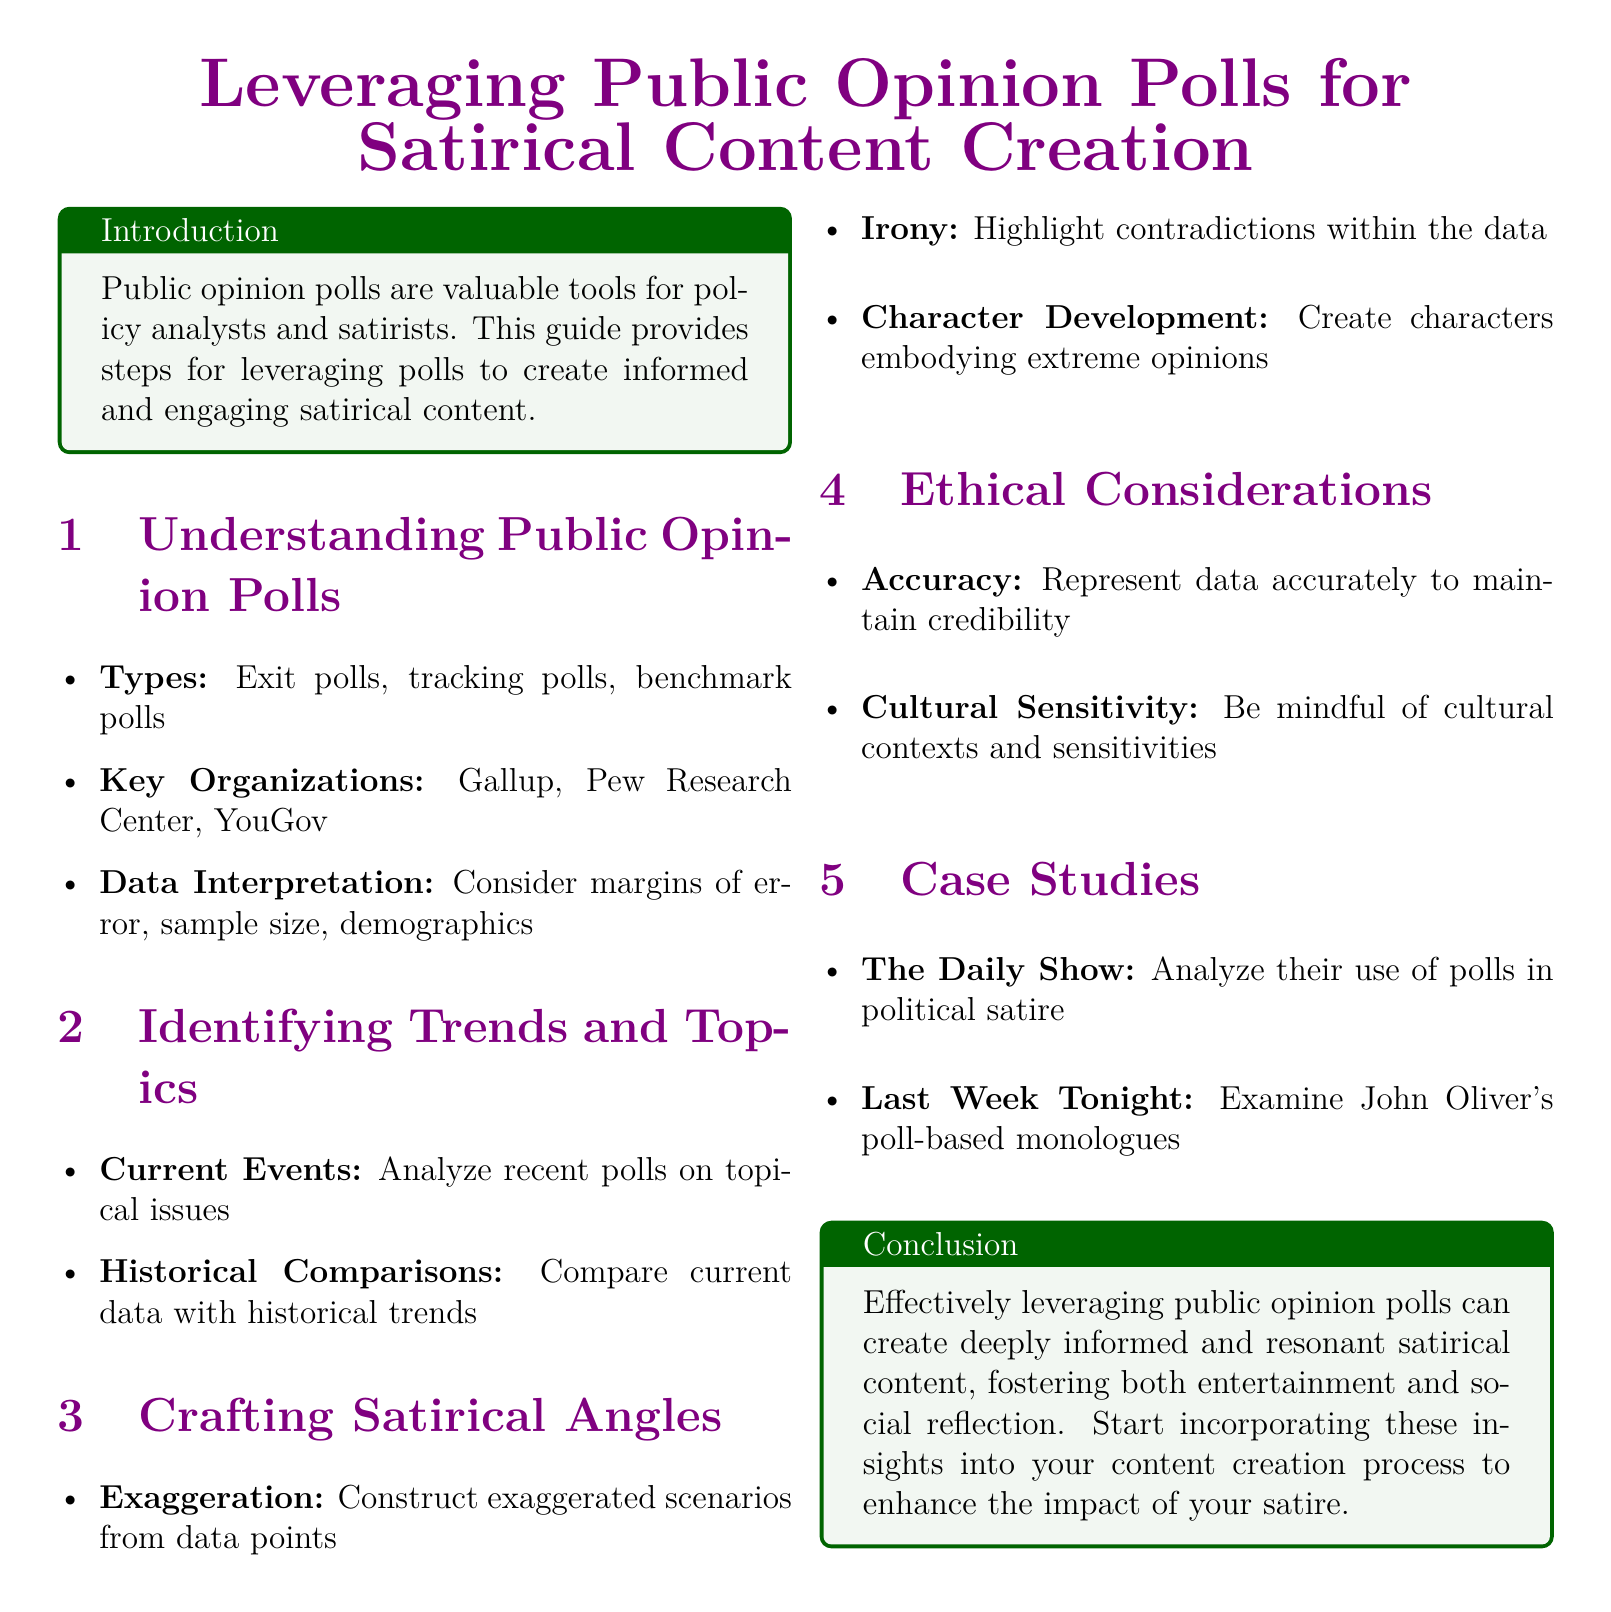What are the types of public opinion polls? The document lists exit polls, tracking polls, and benchmark polls as the types of public opinion polls.
Answer: Exit polls, tracking polls, benchmark polls Which organizations are key in public opinion polling? The document mentions Gallup, Pew Research Center, and YouGov as key organizations.
Answer: Gallup, Pew Research Center, YouGov What is one method for crafting satirical angles? The document suggests exaggeration, irony, and character development as methods to craft satirical angles, focusing on exaggeration for this question.
Answer: Exaggeration What is a crucial ethical consideration in satirical content creation? The document states that accuracy is a crucial ethical consideration.
Answer: Accuracy Which case study involves political satire analysis? The document includes The Daily Show as a case study for analyzing political satire.
Answer: The Daily Show How can public opinion polls enhance satire? The document concludes that they can create informed and resonant satirical content.
Answer: Informed and resonant satirical content What color is used for section titles? The document utilizes the color purple for section titles.
Answer: Purple 